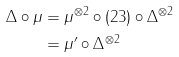<formula> <loc_0><loc_0><loc_500><loc_500>\Delta \circ \mu & = \mu ^ { \otimes 2 } \circ ( 2 3 ) \circ \Delta ^ { \otimes 2 } \\ & = \mu ^ { \prime } \circ \Delta ^ { \otimes 2 }</formula> 